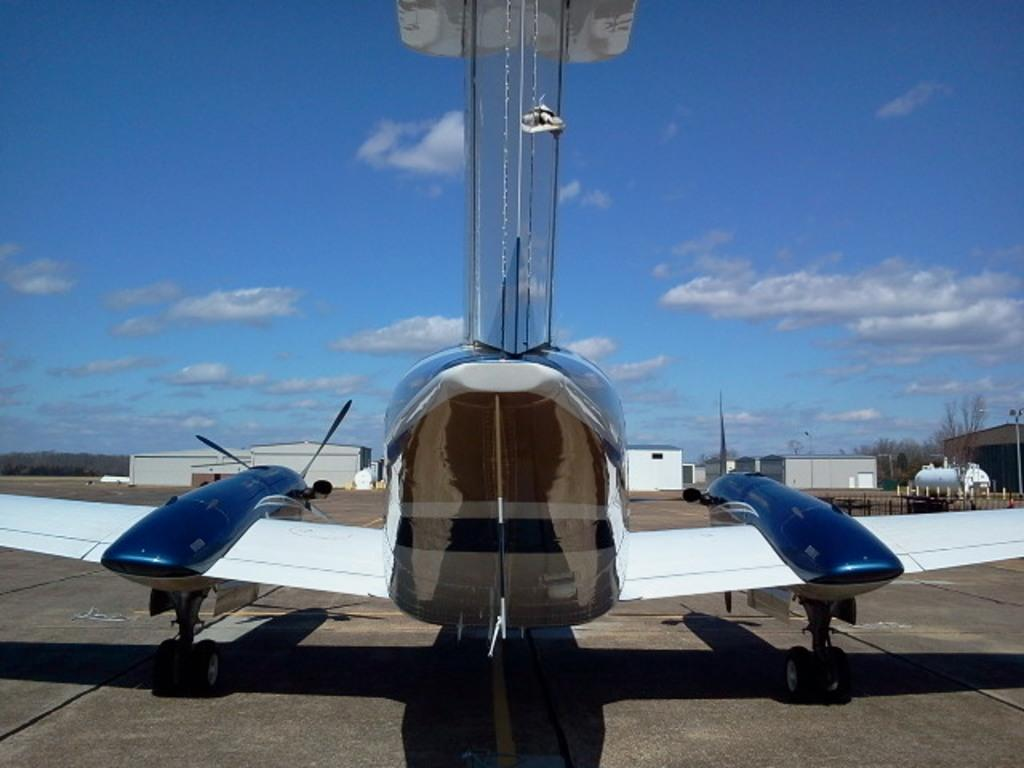What is the main subject of the image? The main subject of the image is an airplane. Where is the airplane located in the image? The airplane is on a runway. What can be seen in the background of the image? There are buildings and trees in the background of the image. What is the condition of the sky in the image? The sky is clear, and it is sunny. How many frogs are hopping on the airplane's wing in the image? There are no frogs present in the image, so it is not possible to determine how many might be hopping on the airplane's wing. 